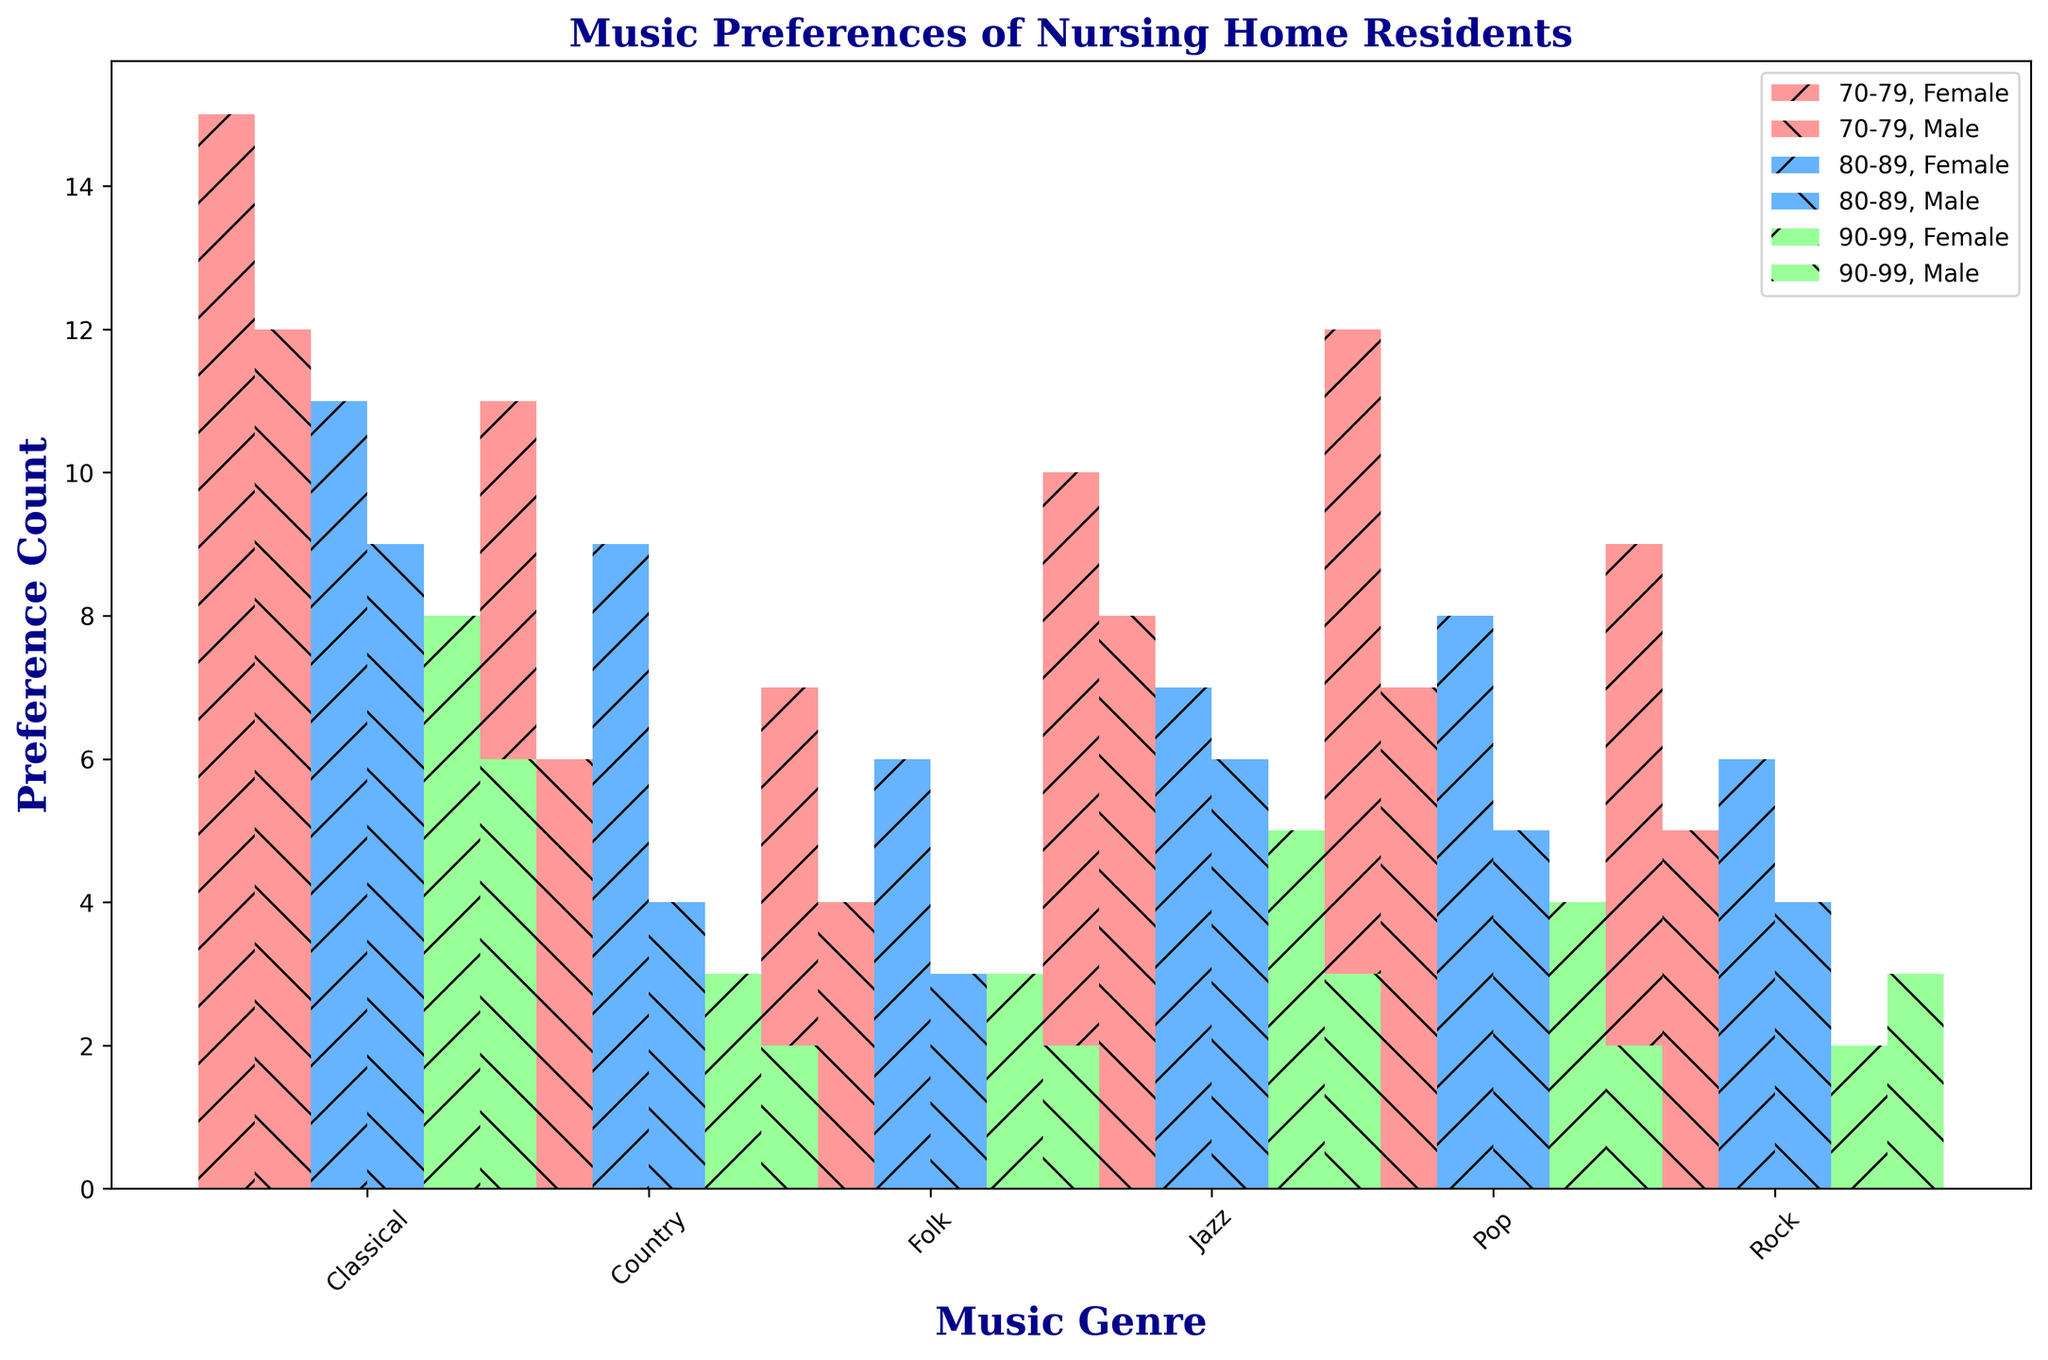What is the preferred genre among residents aged 70-79, both male and female? To find the preferred genre, look for the genre with the tallest bars in the age group 70-79 (both male and female). For males, Pop is the highest. For females, Classical is the highest.
Answer: Males: Pop, Females: Classical Which gender in the 80-89 age group has a higher preference for Jazz? Compare the height of the Jazz bars for both males and females in the 80-89 age group. The female bar is higher than the male bar.
Answer: Female Which genre shows the least preference among males aged 90-99? Look at the bars corresponding to males aged 90-99 across all genres. The Rock bar is the shortest.
Answer: Rock How does the preference for Classical music compare between females aged 70-79 and males aged 90-99? Look at the heights of the Classical music bars for females aged 70-79 and males aged 90-99. The bar for females 70-79 is significantly higher than for males 90-99.
Answer: Females (70-79) > Males (90-99) What is the total preference count for Country music across all age groups and genders? Sum the heights of all Country music bars for each age group and gender. 6+4+2+11+9+3=35.
Answer: 35 Which age group has the highest preference for Folk music? Compare the heights of the Folk bars across all age groups. The 70-79 age group has higher bars than the 80-89 and 90-99 groups.
Answer: 70-79 Which gender overall has a higher preference for Classical music? Compare the combined heights of the Classical music bars for both genders across all age groups. Females have taller bars overall than males.
Answer: Female What is the difference in preference counts for Rock music between females aged 70-79 and females aged 90-99? Subtract the height of the Rock bar for females aged 90-99 from the height of the Rock bar for females aged 70-79. 9 - 2 = 7.
Answer: 7 Which age group has the least preference for Pop music? Look at the bars for Pop music across all age groups. The 90-99 age group has the shortest bars for both males and females.
Answer: 90-99 In the 70-79 age group, which genre has a higher preference among females compared to males? Compare the height of bars between females and males in the 70-79 age group for each genre. Classical, Rock, Jazz, Pop, and Country all show higher preference among females compared to males in this age group.
Answer: Classical, Rock, Jazz, Pop, and Country 